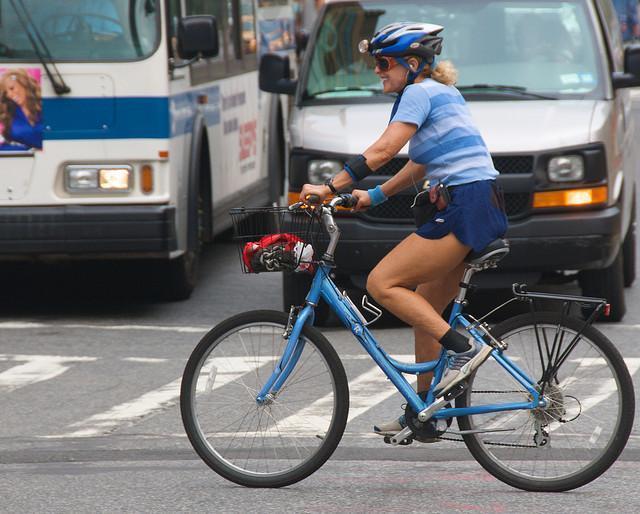How many people are there?
Give a very brief answer. 2. 